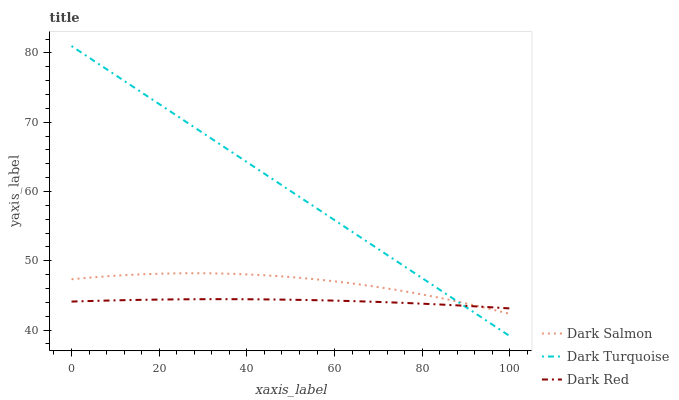Does Dark Red have the minimum area under the curve?
Answer yes or no. Yes. Does Dark Turquoise have the maximum area under the curve?
Answer yes or no. Yes. Does Dark Salmon have the minimum area under the curve?
Answer yes or no. No. Does Dark Salmon have the maximum area under the curve?
Answer yes or no. No. Is Dark Turquoise the smoothest?
Answer yes or no. Yes. Is Dark Salmon the roughest?
Answer yes or no. Yes. Is Dark Red the smoothest?
Answer yes or no. No. Is Dark Red the roughest?
Answer yes or no. No. Does Dark Turquoise have the lowest value?
Answer yes or no. Yes. Does Dark Salmon have the lowest value?
Answer yes or no. No. Does Dark Turquoise have the highest value?
Answer yes or no. Yes. Does Dark Salmon have the highest value?
Answer yes or no. No. Does Dark Turquoise intersect Dark Salmon?
Answer yes or no. Yes. Is Dark Turquoise less than Dark Salmon?
Answer yes or no. No. Is Dark Turquoise greater than Dark Salmon?
Answer yes or no. No. 